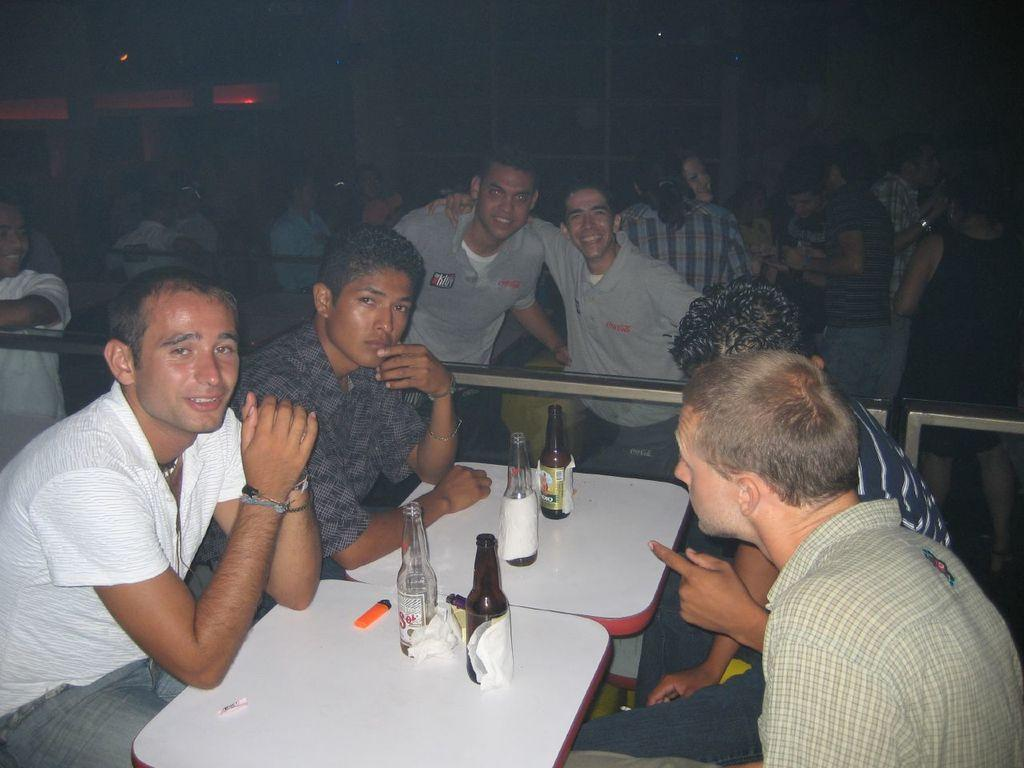What are the people in the image doing? There are people sitting and standing in the image. Can you describe the table in the image? There are empty bottles and tissue papers on the table. What might the people sitting and standing be doing near the table? They might be having a conversation or engaging in some activity together. What type of stove can be seen in the image? There is no stove present in the image. 